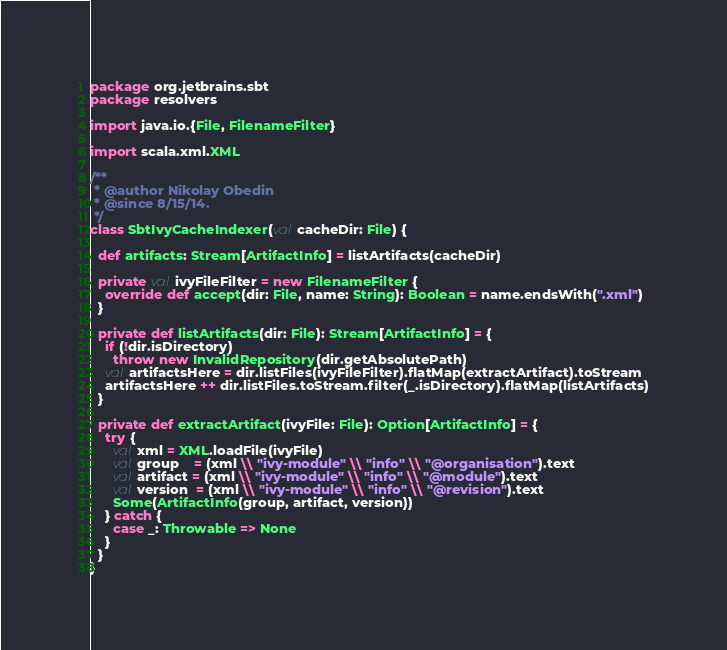Convert code to text. <code><loc_0><loc_0><loc_500><loc_500><_Scala_>package org.jetbrains.sbt
package resolvers

import java.io.{File, FilenameFilter}

import scala.xml.XML

/**
 * @author Nikolay Obedin
 * @since 8/15/14.
 */
class SbtIvyCacheIndexer(val cacheDir: File) {

  def artifacts: Stream[ArtifactInfo] = listArtifacts(cacheDir)

  private val ivyFileFilter = new FilenameFilter {
    override def accept(dir: File, name: String): Boolean = name.endsWith(".xml")
  }

  private def listArtifacts(dir: File): Stream[ArtifactInfo] = {
    if (!dir.isDirectory)
      throw new InvalidRepository(dir.getAbsolutePath)
    val artifactsHere = dir.listFiles(ivyFileFilter).flatMap(extractArtifact).toStream
    artifactsHere ++ dir.listFiles.toStream.filter(_.isDirectory).flatMap(listArtifacts)
  }

  private def extractArtifact(ivyFile: File): Option[ArtifactInfo] = {
    try {
      val xml = XML.loadFile(ivyFile)
      val group    = (xml \\ "ivy-module" \\ "info" \\ "@organisation").text
      val artifact = (xml \\ "ivy-module" \\ "info" \\ "@module").text
      val version  = (xml \\ "ivy-module" \\ "info" \\ "@revision").text
      Some(ArtifactInfo(group, artifact, version))
    } catch {
      case _: Throwable => None
    }
  }
}

</code> 